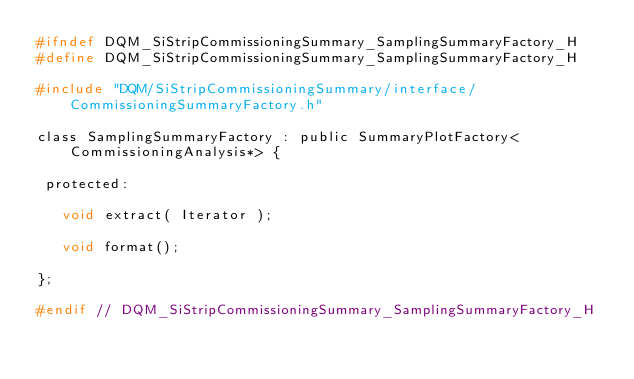Convert code to text. <code><loc_0><loc_0><loc_500><loc_500><_C_>#ifndef DQM_SiStripCommissioningSummary_SamplingSummaryFactory_H
#define DQM_SiStripCommissioningSummary_SamplingSummaryFactory_H

#include "DQM/SiStripCommissioningSummary/interface/CommissioningSummaryFactory.h"

class SamplingSummaryFactory : public SummaryPlotFactory<CommissioningAnalysis*> {

 protected:

   void extract( Iterator );

   void format();

};

#endif // DQM_SiStripCommissioningSummary_SamplingSummaryFactory_H
</code> 